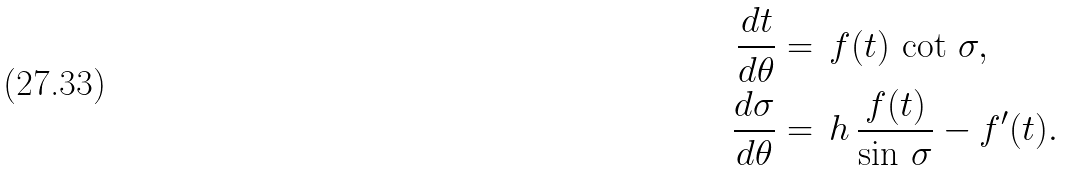<formula> <loc_0><loc_0><loc_500><loc_500>\frac { d t } { d \theta } & = \, f ( t ) \, \cot \, \sigma , \\ \frac { d \sigma } { d \theta } & = \, h \, \frac { f ( t ) } { \sin \, \sigma } - f ^ { \prime } ( t ) .</formula> 